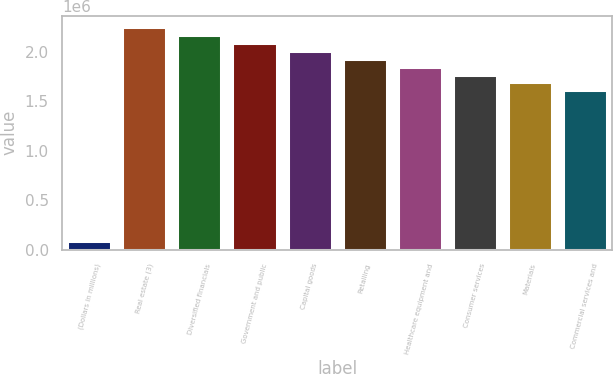<chart> <loc_0><loc_0><loc_500><loc_500><bar_chart><fcel>(Dollars in millions)<fcel>Real estate (3)<fcel>Diversified financials<fcel>Government and public<fcel>Capital goods<fcel>Retailing<fcel>Healthcare equipment and<fcel>Consumer services<fcel>Materials<fcel>Commercial services and<nl><fcel>82173<fcel>2.25165e+06<fcel>2.1713e+06<fcel>2.09095e+06<fcel>2.0106e+06<fcel>1.93025e+06<fcel>1.8499e+06<fcel>1.76954e+06<fcel>1.68919e+06<fcel>1.60884e+06<nl></chart> 